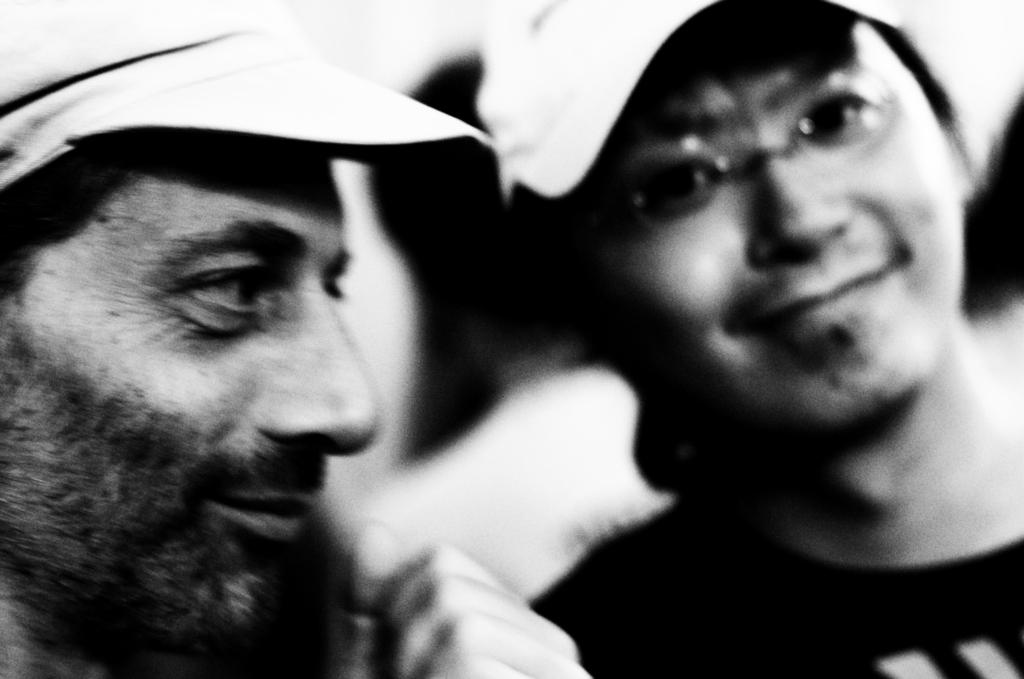How many people are in the image? There are two men in the image. What are the men wearing on their heads? Both men are wearing caps. What type of liquid can be seen flowing from the clover in the image? There is no clover or liquid present in the image. 